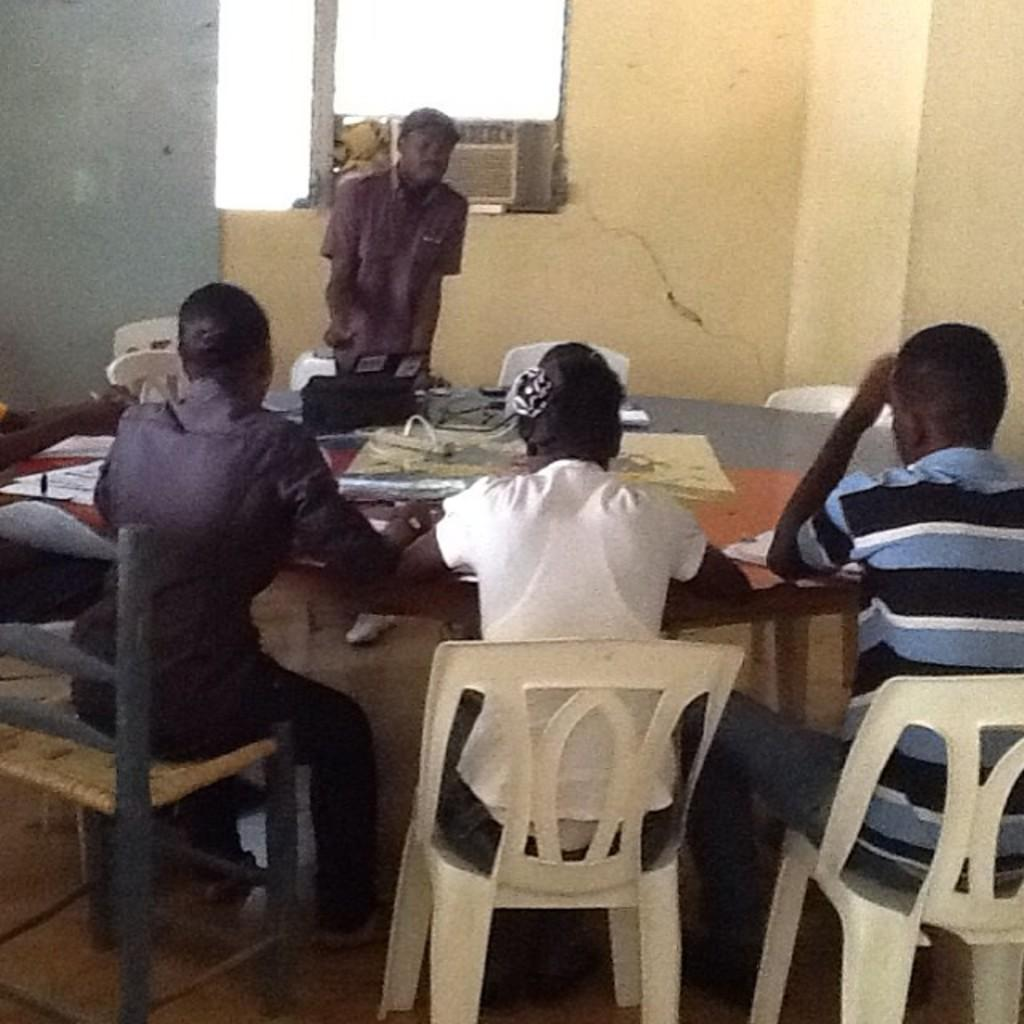What are the people in the image doing? The people in the image are sitting on chairs. Are there any people standing in the image? Yes, there is at least one person standing in the image. What is on the table in the image? Papers are present on the table. Can you describe the window in the image? The window is on a wall. What type of liquid can be seen flowing from the person's leg in the image? There is no liquid flowing from anyone's leg in the image. Is there a swing present in the image? No, there is no swing present in the image. 